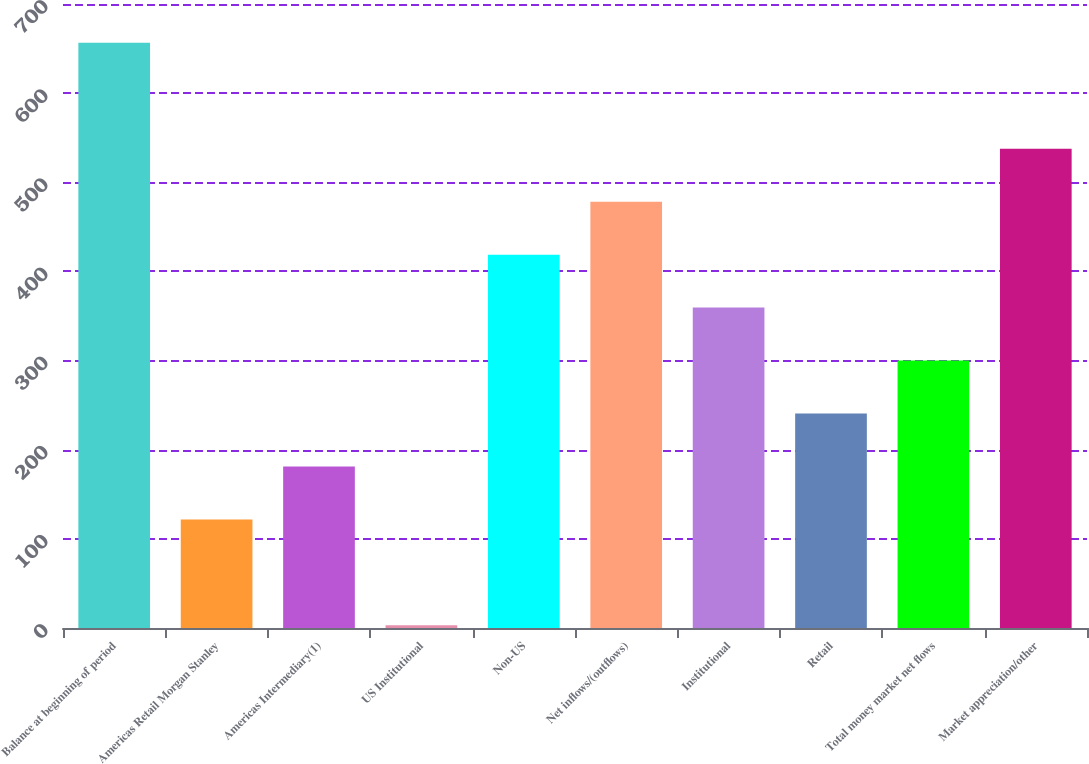<chart> <loc_0><loc_0><loc_500><loc_500><bar_chart><fcel>Balance at beginning of period<fcel>Americas Retail Morgan Stanley<fcel>Americas Intermediary(1)<fcel>US Institutional<fcel>Non-US<fcel>Net inflows/(outflows)<fcel>Institutional<fcel>Retail<fcel>Total money market net flows<fcel>Market appreciation/other<nl><fcel>656.4<fcel>121.8<fcel>181.2<fcel>3<fcel>418.8<fcel>478.2<fcel>359.4<fcel>240.6<fcel>300<fcel>537.6<nl></chart> 